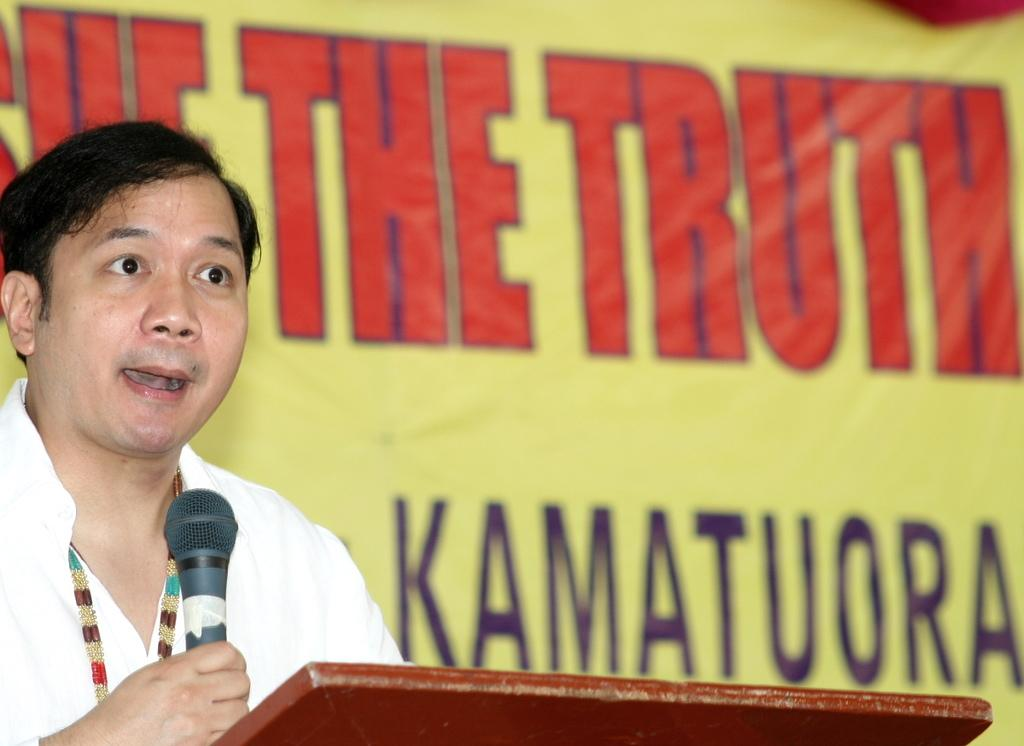What is the main subject of the image? There is a person in the image. What is the person holding in the image? The person is holding a microphone. What can be seen in the background of the image? There is a banner in the background of the image. What type of reward can be seen hanging from the microphone in the image? There is no reward hanging from the microphone in the image. What type of scent is associated with the person in the image? There is no mention of scent in the image, and it cannot be determined from the image. 